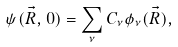Convert formula to latex. <formula><loc_0><loc_0><loc_500><loc_500>\psi ( \vec { R } , 0 ) = \sum _ { \nu } C _ { \nu } \phi _ { \nu } ( \vec { R } ) ,</formula> 